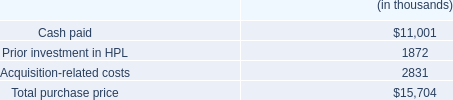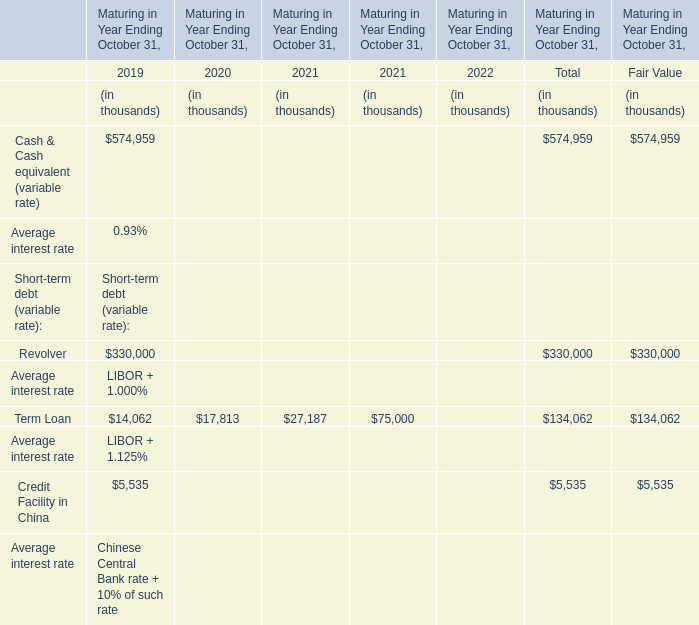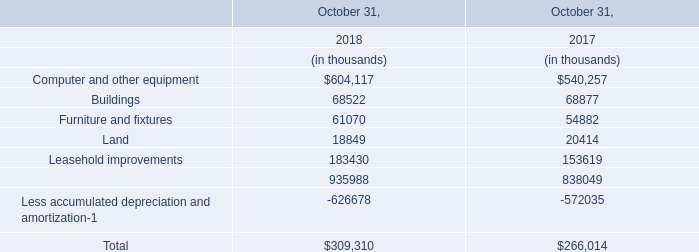what percentage of the total purchase price is represented by intangible assets? 
Computations: ((8.5 * 1000) / 15704)
Answer: 0.54126. 